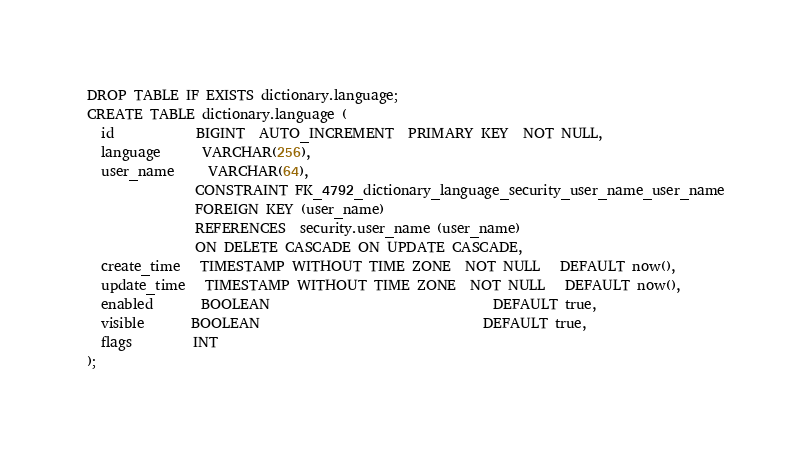Convert code to text. <code><loc_0><loc_0><loc_500><loc_500><_SQL_>DROP TABLE IF EXISTS dictionary.language;
CREATE TABLE dictionary.language (
  id            BIGINT  AUTO_INCREMENT  PRIMARY KEY  NOT NULL,
  language      VARCHAR(256),
  user_name     VARCHAR(64),
                CONSTRAINT FK_4792_dictionary_language_security_user_name_user_name
                FOREIGN KEY (user_name)
                REFERENCES  security.user_name (user_name)
                ON DELETE CASCADE ON UPDATE CASCADE,
  create_time   TIMESTAMP WITHOUT TIME ZONE  NOT NULL   DEFAULT now(),
  update_time   TIMESTAMP WITHOUT TIME ZONE  NOT NULL   DEFAULT now(),
  enabled       BOOLEAN                                 DEFAULT true,
  visible       BOOLEAN                                 DEFAULT true,
  flags         INT
);
</code> 